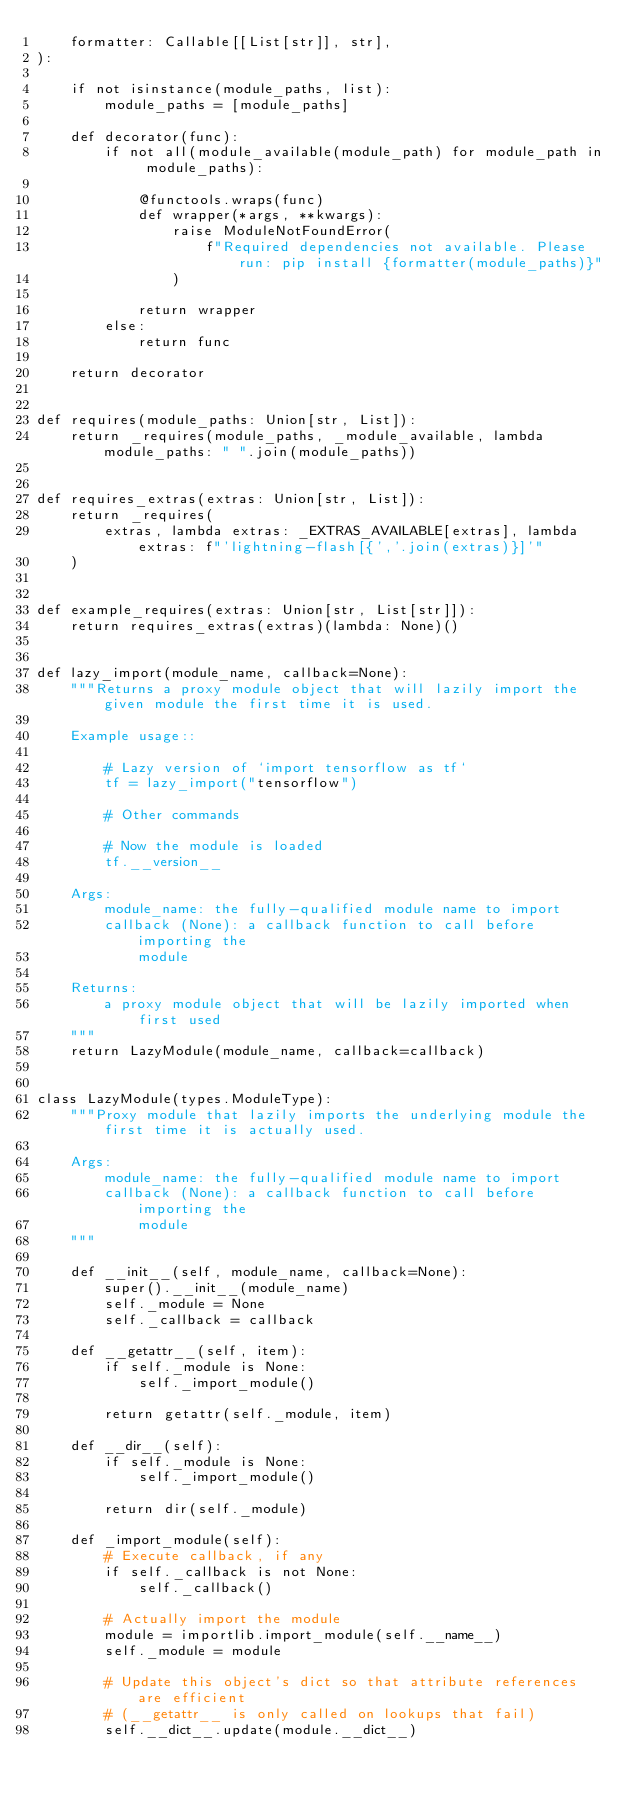Convert code to text. <code><loc_0><loc_0><loc_500><loc_500><_Python_>    formatter: Callable[[List[str]], str],
):

    if not isinstance(module_paths, list):
        module_paths = [module_paths]

    def decorator(func):
        if not all(module_available(module_path) for module_path in module_paths):

            @functools.wraps(func)
            def wrapper(*args, **kwargs):
                raise ModuleNotFoundError(
                    f"Required dependencies not available. Please run: pip install {formatter(module_paths)}"
                )

            return wrapper
        else:
            return func

    return decorator


def requires(module_paths: Union[str, List]):
    return _requires(module_paths, _module_available, lambda module_paths: " ".join(module_paths))


def requires_extras(extras: Union[str, List]):
    return _requires(
        extras, lambda extras: _EXTRAS_AVAILABLE[extras], lambda extras: f"'lightning-flash[{','.join(extras)}]'"
    )


def example_requires(extras: Union[str, List[str]]):
    return requires_extras(extras)(lambda: None)()


def lazy_import(module_name, callback=None):
    """Returns a proxy module object that will lazily import the given module the first time it is used.

    Example usage::

        # Lazy version of `import tensorflow as tf`
        tf = lazy_import("tensorflow")

        # Other commands

        # Now the module is loaded
        tf.__version__

    Args:
        module_name: the fully-qualified module name to import
        callback (None): a callback function to call before importing the
            module

    Returns:
        a proxy module object that will be lazily imported when first used
    """
    return LazyModule(module_name, callback=callback)


class LazyModule(types.ModuleType):
    """Proxy module that lazily imports the underlying module the first time it is actually used.

    Args:
        module_name: the fully-qualified module name to import
        callback (None): a callback function to call before importing the
            module
    """

    def __init__(self, module_name, callback=None):
        super().__init__(module_name)
        self._module = None
        self._callback = callback

    def __getattr__(self, item):
        if self._module is None:
            self._import_module()

        return getattr(self._module, item)

    def __dir__(self):
        if self._module is None:
            self._import_module()

        return dir(self._module)

    def _import_module(self):
        # Execute callback, if any
        if self._callback is not None:
            self._callback()

        # Actually import the module
        module = importlib.import_module(self.__name__)
        self._module = module

        # Update this object's dict so that attribute references are efficient
        # (__getattr__ is only called on lookups that fail)
        self.__dict__.update(module.__dict__)
</code> 